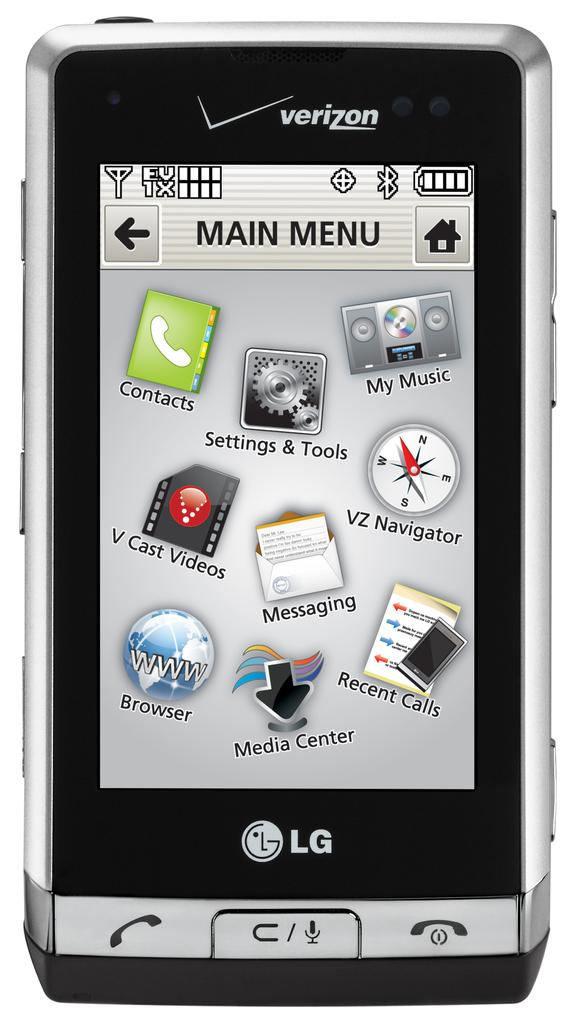<image>
Write a terse but informative summary of the picture. The brand on the phone is named Verizon 